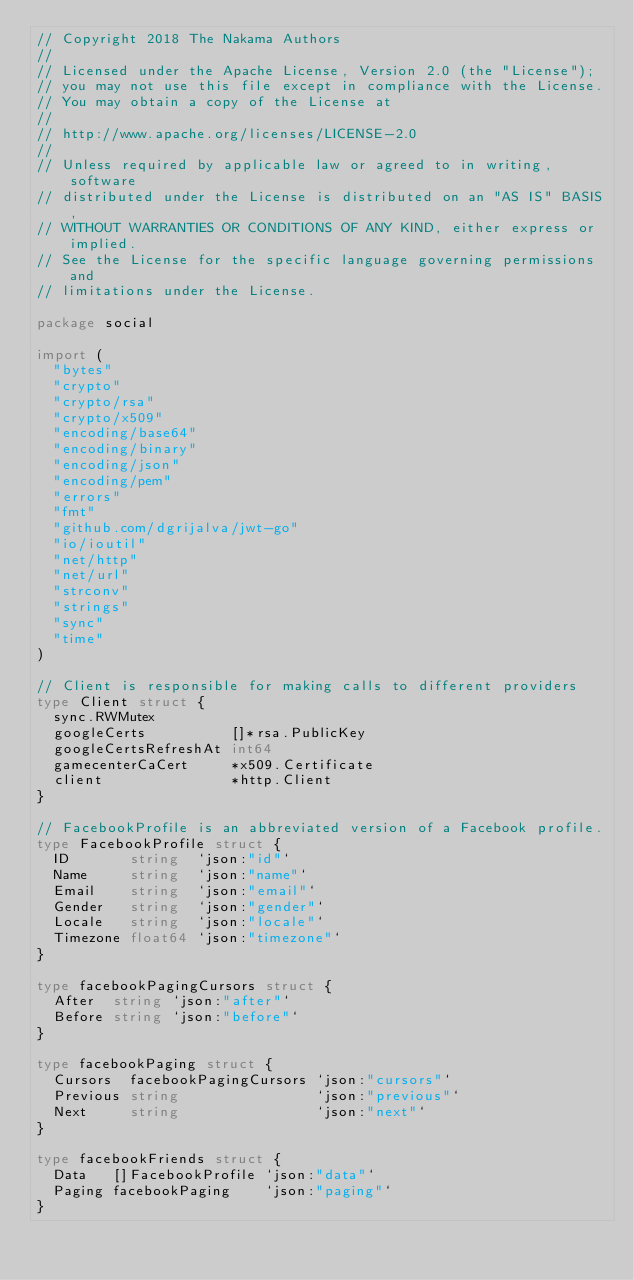<code> <loc_0><loc_0><loc_500><loc_500><_Go_>// Copyright 2018 The Nakama Authors
//
// Licensed under the Apache License, Version 2.0 (the "License");
// you may not use this file except in compliance with the License.
// You may obtain a copy of the License at
//
// http://www.apache.org/licenses/LICENSE-2.0
//
// Unless required by applicable law or agreed to in writing, software
// distributed under the License is distributed on an "AS IS" BASIS,
// WITHOUT WARRANTIES OR CONDITIONS OF ANY KIND, either express or implied.
// See the License for the specific language governing permissions and
// limitations under the License.

package social

import (
	"bytes"
	"crypto"
	"crypto/rsa"
	"crypto/x509"
	"encoding/base64"
	"encoding/binary"
	"encoding/json"
	"encoding/pem"
	"errors"
	"fmt"
	"github.com/dgrijalva/jwt-go"
	"io/ioutil"
	"net/http"
	"net/url"
	"strconv"
	"strings"
	"sync"
	"time"
)

// Client is responsible for making calls to different providers
type Client struct {
	sync.RWMutex
	googleCerts          []*rsa.PublicKey
	googleCertsRefreshAt int64
	gamecenterCaCert     *x509.Certificate
	client               *http.Client
}

// FacebookProfile is an abbreviated version of a Facebook profile.
type FacebookProfile struct {
	ID       string  `json:"id"`
	Name     string  `json:"name"`
	Email    string  `json:"email"`
	Gender   string  `json:"gender"`
	Locale   string  `json:"locale"`
	Timezone float64 `json:"timezone"`
}

type facebookPagingCursors struct {
	After  string `json:"after"`
	Before string `json:"before"`
}

type facebookPaging struct {
	Cursors  facebookPagingCursors `json:"cursors"`
	Previous string                `json:"previous"`
	Next     string                `json:"next"`
}

type facebookFriends struct {
	Data   []FacebookProfile `json:"data"`
	Paging facebookPaging    `json:"paging"`
}
</code> 